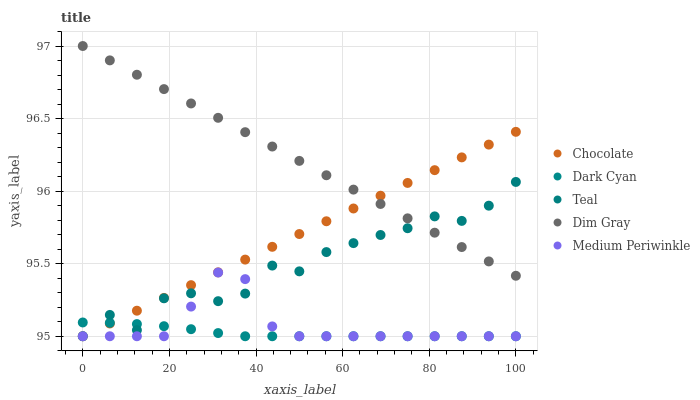Does Dark Cyan have the minimum area under the curve?
Answer yes or no. Yes. Does Dim Gray have the maximum area under the curve?
Answer yes or no. Yes. Does Medium Periwinkle have the minimum area under the curve?
Answer yes or no. No. Does Medium Periwinkle have the maximum area under the curve?
Answer yes or no. No. Is Dim Gray the smoothest?
Answer yes or no. Yes. Is Teal the roughest?
Answer yes or no. Yes. Is Medium Periwinkle the smoothest?
Answer yes or no. No. Is Medium Periwinkle the roughest?
Answer yes or no. No. Does Dark Cyan have the lowest value?
Answer yes or no. Yes. Does Dim Gray have the lowest value?
Answer yes or no. No. Does Dim Gray have the highest value?
Answer yes or no. Yes. Does Medium Periwinkle have the highest value?
Answer yes or no. No. Is Dark Cyan less than Dim Gray?
Answer yes or no. Yes. Is Dim Gray greater than Medium Periwinkle?
Answer yes or no. Yes. Does Dark Cyan intersect Chocolate?
Answer yes or no. Yes. Is Dark Cyan less than Chocolate?
Answer yes or no. No. Is Dark Cyan greater than Chocolate?
Answer yes or no. No. Does Dark Cyan intersect Dim Gray?
Answer yes or no. No. 